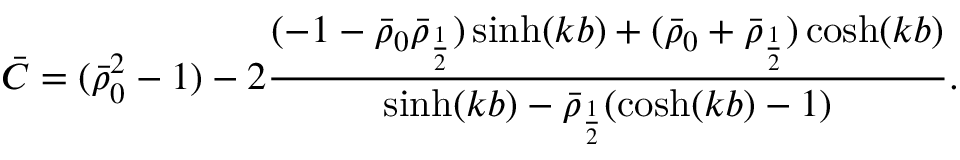Convert formula to latex. <formula><loc_0><loc_0><loc_500><loc_500>\bar { C } = ( \bar { \rho } _ { 0 } ^ { 2 } - 1 ) - 2 \frac { ( - 1 - \bar { \rho } _ { 0 } \bar { \rho } _ { \frac { 1 } { 2 } } ) \sinh ( k b ) + ( \bar { \rho } _ { 0 } + \bar { \rho } _ { \frac { 1 } { 2 } } ) \cosh ( k b ) } { \sinh ( k b ) - \bar { \rho } _ { \frac { 1 } { 2 } } ( \cosh ( k b ) - 1 ) } .</formula> 